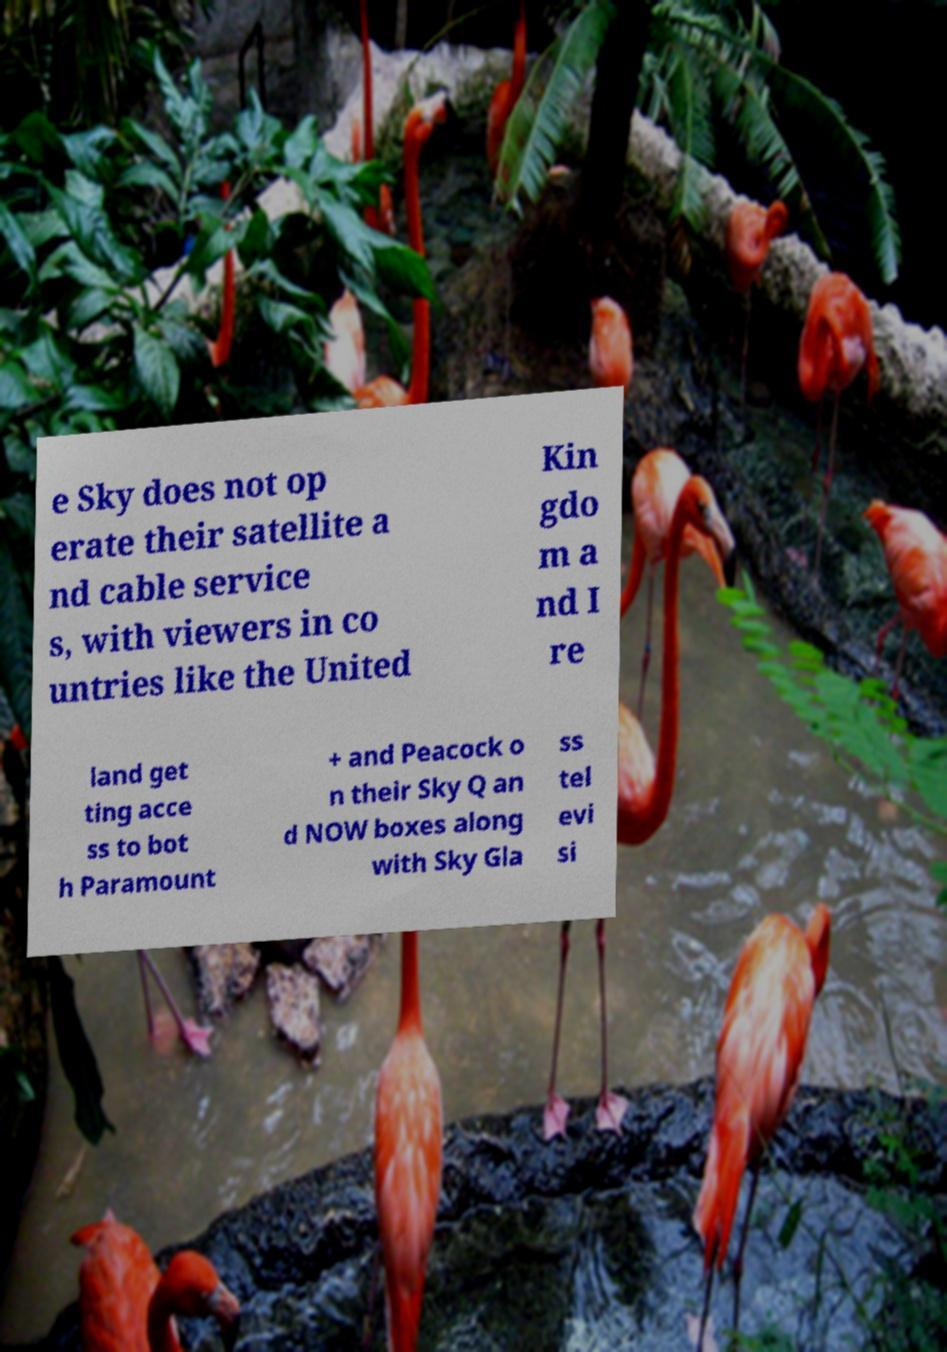There's text embedded in this image that I need extracted. Can you transcribe it verbatim? e Sky does not op erate their satellite a nd cable service s, with viewers in co untries like the United Kin gdo m a nd I re land get ting acce ss to bot h Paramount + and Peacock o n their Sky Q an d NOW boxes along with Sky Gla ss tel evi si 